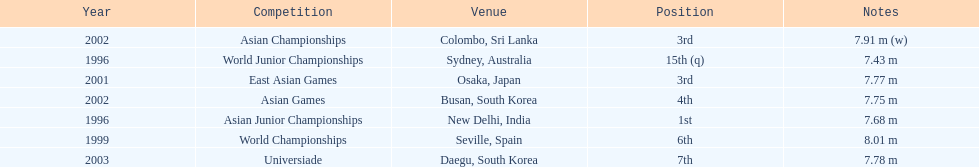In what year was the position of 3rd first achieved? 2001. 